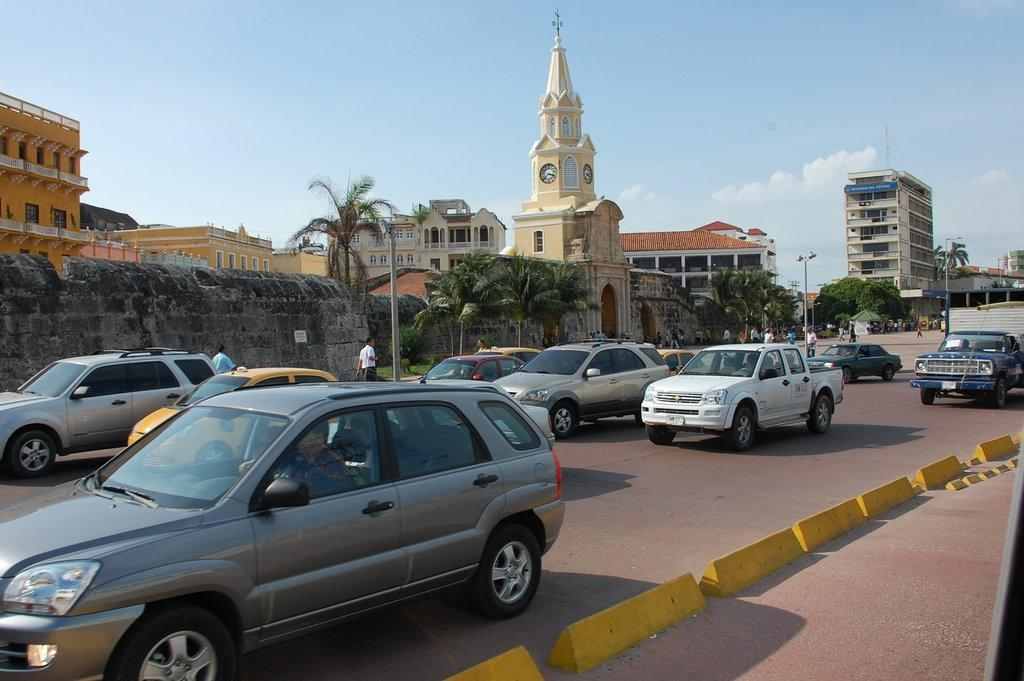What can be seen on the road in the image? There are many cars on the road in the image. What separates the lanes of traffic in the image? There is a road divider at the bottom of the image. What is visible in the background of the image? There is a wall, buildings, trees, poles, and the sky visible in the background of the image. What is the condition of the sky in the image? The sky is visible in the background of the image, and clouds are present. Can you see an ant carrying a whip in the image? There is no ant or whip present in the image. 